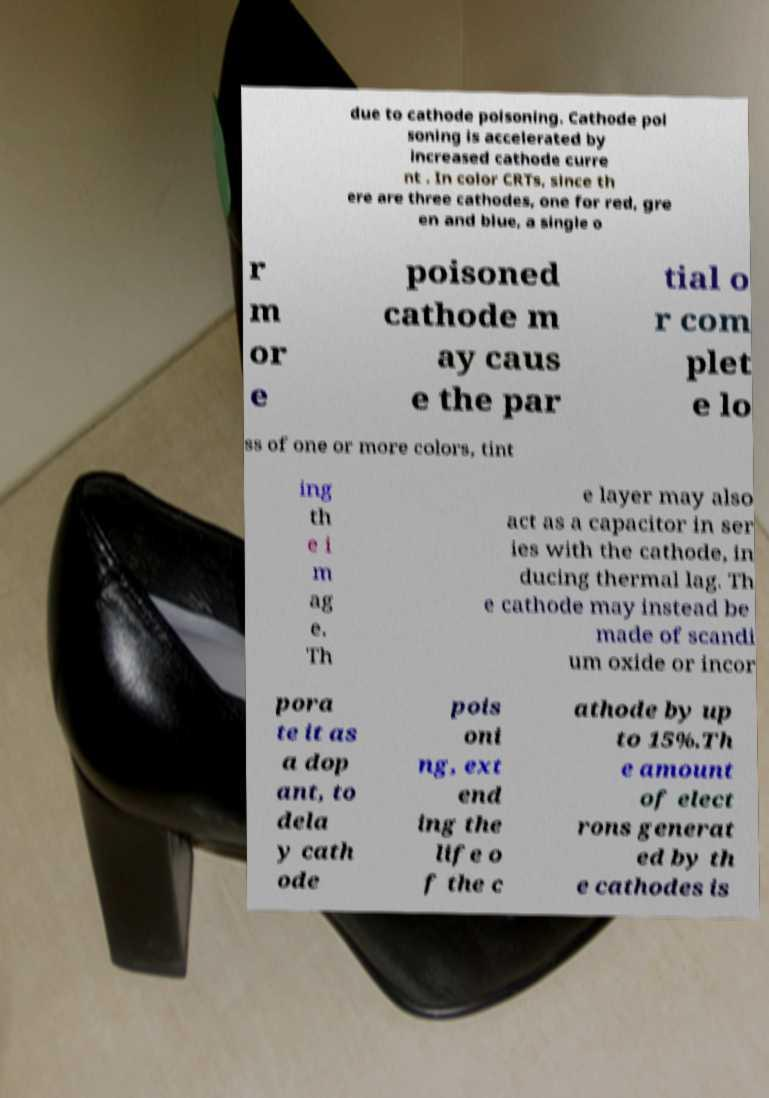Can you accurately transcribe the text from the provided image for me? due to cathode poisoning. Cathode poi soning is accelerated by increased cathode curre nt . In color CRTs, since th ere are three cathodes, one for red, gre en and blue, a single o r m or e poisoned cathode m ay caus e the par tial o r com plet e lo ss of one or more colors, tint ing th e i m ag e. Th e layer may also act as a capacitor in ser ies with the cathode, in ducing thermal lag. Th e cathode may instead be made of scandi um oxide or incor pora te it as a dop ant, to dela y cath ode pois oni ng, ext end ing the life o f the c athode by up to 15%.Th e amount of elect rons generat ed by th e cathodes is 